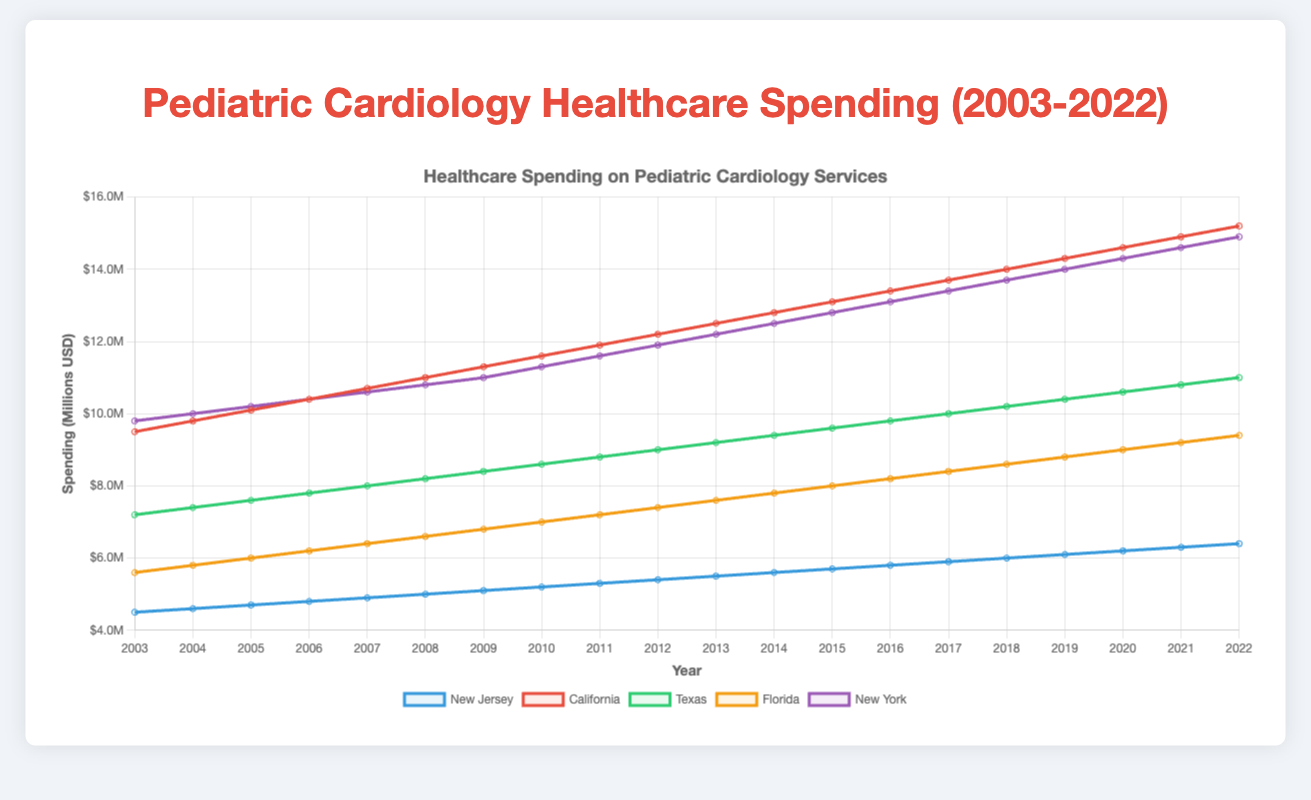What trends are observed in the pediatric cardiology spending in New Jersey and California from 2003 to 2022? Both New Jersey and California show a consistent upward trend in pediatric cardiology spending from 2003 to 2022, with California experiencing a sharper increase.
Answer: Upward trend Which state had the highest pediatric cardiology spending in 2015? In 2015, California had the highest pediatric cardiology spending among the states listed in the figure.
Answer: California By how much did the spending in Texas increase from 2003 to 2022? The spending in Texas was $7,200,000 in 2003 and $11,000,000 in 2022. The increase is calculated as $11,000,000 - $7,200,000 = $3,800,000.
Answer: $3,800,000 Which state has shown the least growth in pediatric cardiology spending over the two decades? Compare the increments in spending for each state from 2003 to 2022. New Jersey had the smallest increment as it increased from $4,500,000 to $6,400,000, an increment of $1,900,000.
Answer: New Jersey What is the average pediatric cardiology spending in Florida from 2003 to 2022? Calculate the average by summing the spending for Florida from 2003 to 2022 and dividing by the number of years. Total spending in Florida is $172,000,000 over 20 years. The average is $172,000,000 / 20 = $8,600,000.
Answer: $8,600,000 In which years did pediatric cardiology spending in New York surpass $10,000,000? From the figure, New York's spending surpassed $10,000,000 starting in 2005 and continued to stay above this amount in subsequent years.
Answer: 2005-2022 Compare the pediatric cardiology spending trends of Florida and Texas. Which state had a greater overall increase over the two decades? Texas showed a consistent increase from $7,200,000 in 2003 to $11,000,000 in 2022, while Florida increased from $5,600,000 to $9,400,000 in the same period. Texas had a greater overall increase: $3,800,000 vs. $3,800,000 for Florida.
Answer: Texas Calculate the average annual increase in spending for California from 2003 to 2022. The total increase for California from 2003 ($9,500,000) to 2022 ($15,200,000) is $5,700,000. Divide this by 19 years (2022 - 2003) to get the annual average increase: $5,700,000 / 19 ≈ $300,000.
Answer: $300,000 Which state had the closest pediatric cardiology spending to $10 million in the year 2014? In 2014, New York had spending closest to $10 million with a value of $12,500,000.
Answer: New York 